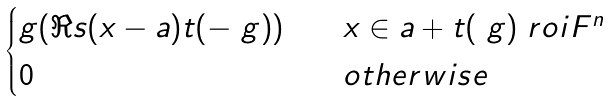<formula> <loc_0><loc_0><loc_500><loc_500>\begin{cases} g ( \Re s { ( x - a ) t ( - \ g ) } ) & \quad x \in a + t ( \ g ) \ r o i { F } ^ { n } \\ 0 & \quad o t h e r w i s e \end{cases}</formula> 